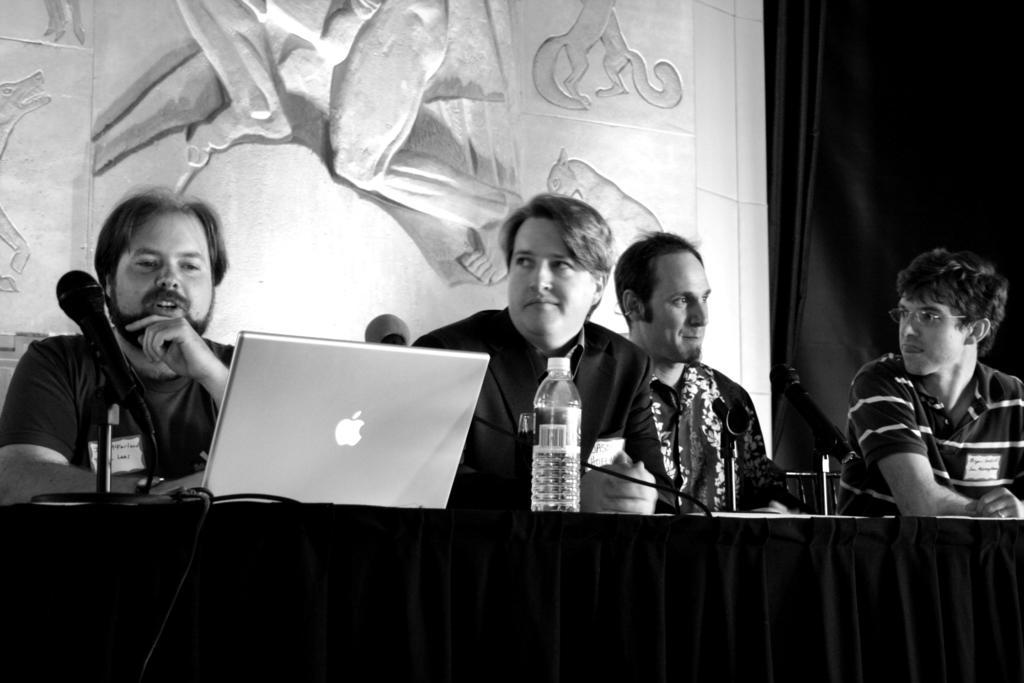Can you describe this image briefly? In this image there are group of people sitting on chairs in front of table where we can see there are microphones, bottle and laptop, behind them there is a wall with some art. 